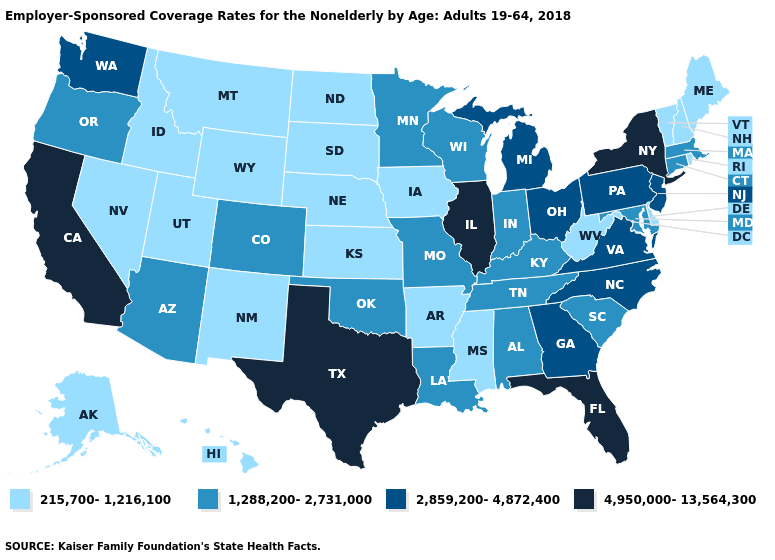Which states have the lowest value in the MidWest?
Quick response, please. Iowa, Kansas, Nebraska, North Dakota, South Dakota. What is the highest value in states that border Maryland?
Keep it brief. 2,859,200-4,872,400. Which states have the lowest value in the USA?
Write a very short answer. Alaska, Arkansas, Delaware, Hawaii, Idaho, Iowa, Kansas, Maine, Mississippi, Montana, Nebraska, Nevada, New Hampshire, New Mexico, North Dakota, Rhode Island, South Dakota, Utah, Vermont, West Virginia, Wyoming. Does Illinois have the lowest value in the USA?
Be succinct. No. What is the value of Hawaii?
Concise answer only. 215,700-1,216,100. Does the first symbol in the legend represent the smallest category?
Short answer required. Yes. Does the map have missing data?
Answer briefly. No. Among the states that border New Hampshire , does Massachusetts have the highest value?
Write a very short answer. Yes. Does the first symbol in the legend represent the smallest category?
Write a very short answer. Yes. Does the map have missing data?
Give a very brief answer. No. Name the states that have a value in the range 1,288,200-2,731,000?
Quick response, please. Alabama, Arizona, Colorado, Connecticut, Indiana, Kentucky, Louisiana, Maryland, Massachusetts, Minnesota, Missouri, Oklahoma, Oregon, South Carolina, Tennessee, Wisconsin. Does Connecticut have the lowest value in the USA?
Short answer required. No. Among the states that border Iowa , which have the highest value?
Concise answer only. Illinois. Among the states that border Iowa , does Illinois have the highest value?
Keep it brief. Yes. What is the highest value in states that border South Dakota?
Answer briefly. 1,288,200-2,731,000. 